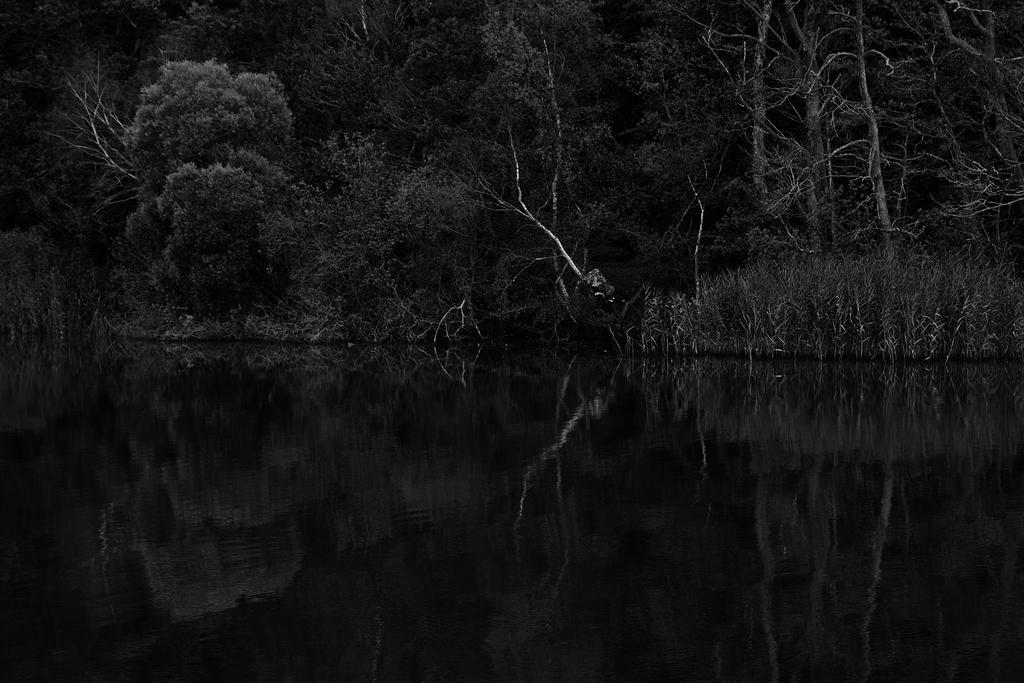Could you give a brief overview of what you see in this image? It is a black and white image, at the bottom there is water. In the middle there are trees in this image. 